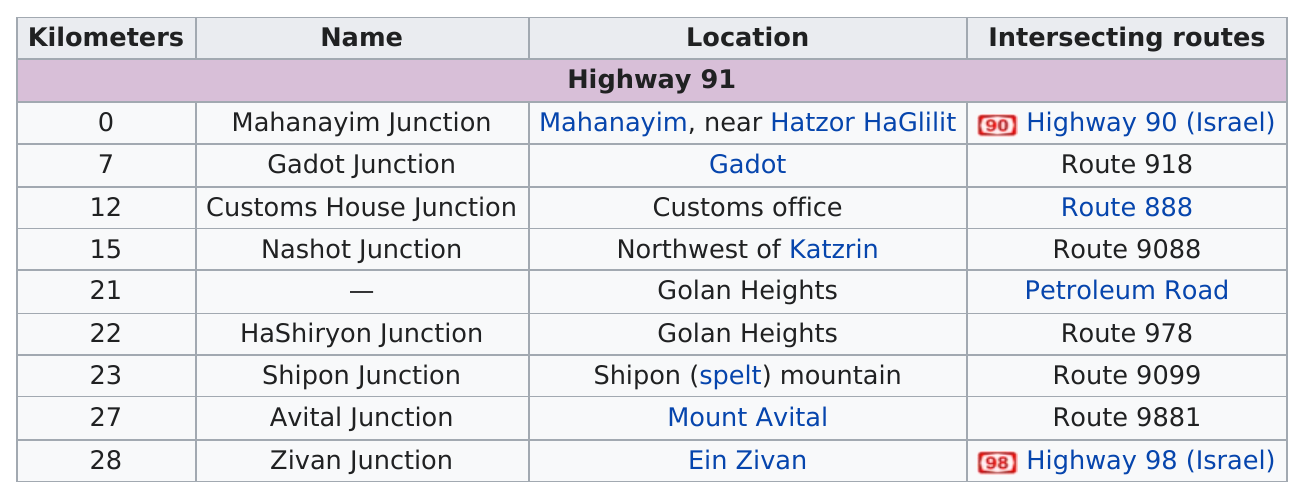List a handful of essential elements in this visual. Zivan Junction is the furthest junction from Mahanayim Junction. The last junction on Highway 91 is known as Zivan Junction. The distance between the Mahanayim junction and the Shipon junction is 23 kilometers. Gadot Junction is the junction on highway 91 that is closer to Ein Zivan. What is the number of routes that intersect with Highway 91? 9. 